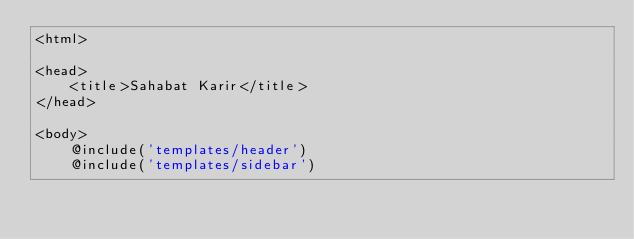Convert code to text. <code><loc_0><loc_0><loc_500><loc_500><_PHP_><html>

<head>
    <title>Sahabat Karir</title>
</head>

<body>
    @include('templates/header')
    @include('templates/sidebar')</code> 